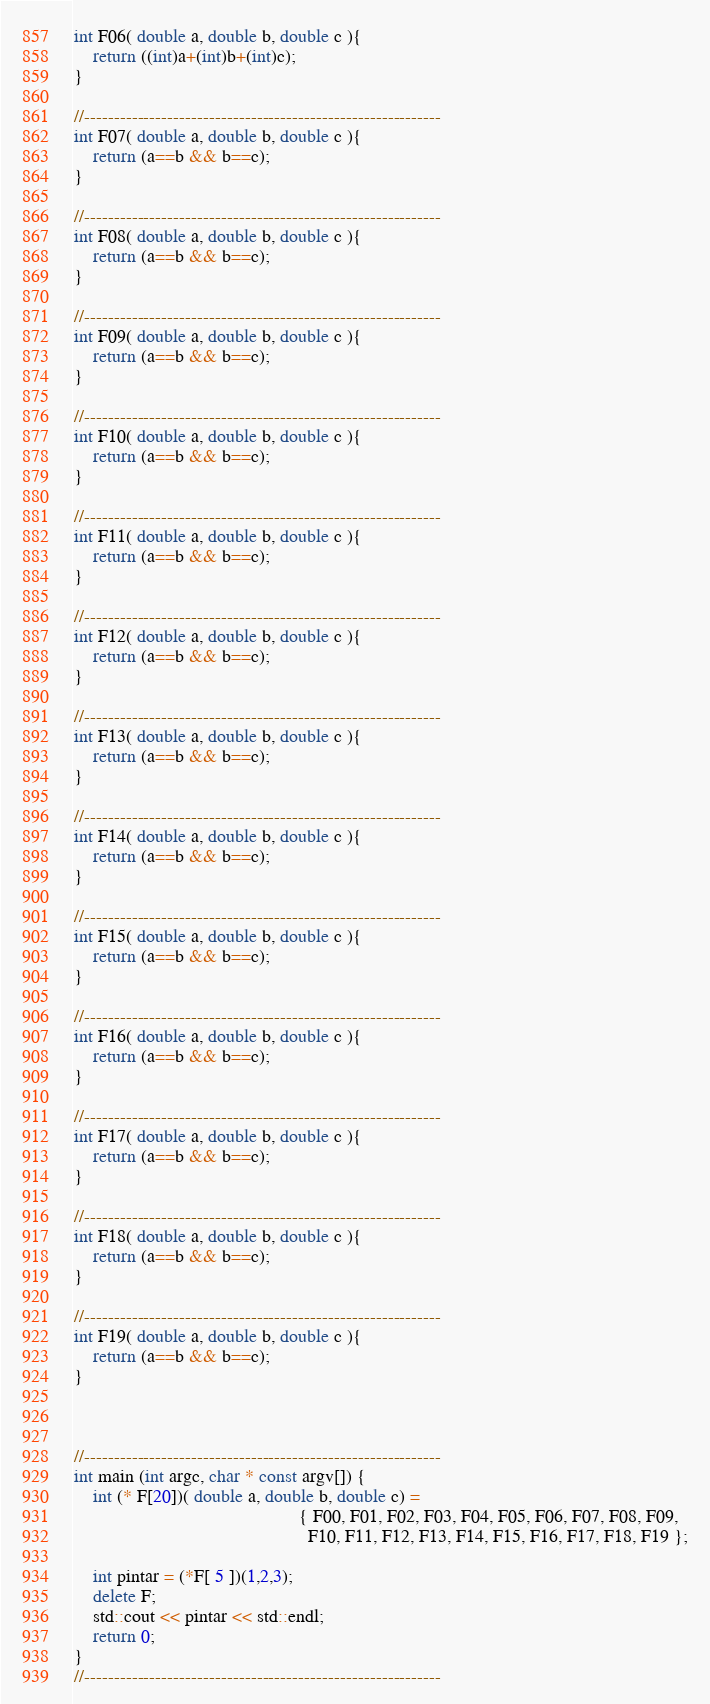<code> <loc_0><loc_0><loc_500><loc_500><_C++_>int F06( double a, double b, double c ){
	return ((int)a+(int)b+(int)c);
}

//------------------------------------------------------------
int F07( double a, double b, double c ){
	return (a==b && b==c);
}

//------------------------------------------------------------
int F08( double a, double b, double c ){
	return (a==b && b==c);
}

//------------------------------------------------------------
int F09( double a, double b, double c ){
	return (a==b && b==c);
}

//------------------------------------------------------------
int F10( double a, double b, double c ){
	return (a==b && b==c);
}

//------------------------------------------------------------
int F11( double a, double b, double c ){
	return (a==b && b==c);
}

//------------------------------------------------------------
int F12( double a, double b, double c ){
	return (a==b && b==c);
}

//------------------------------------------------------------
int F13( double a, double b, double c ){
	return (a==b && b==c);
}

//------------------------------------------------------------
int F14( double a, double b, double c ){
	return (a==b && b==c);
}

//------------------------------------------------------------
int F15( double a, double b, double c ){
	return (a==b && b==c);
}

//------------------------------------------------------------
int F16( double a, double b, double c ){
	return (a==b && b==c);
}

//------------------------------------------------------------
int F17( double a, double b, double c ){
	return (a==b && b==c);
}

//------------------------------------------------------------
int F18( double a, double b, double c ){
	return (a==b && b==c);
}

//------------------------------------------------------------
int F19( double a, double b, double c ){
	return (a==b && b==c);
}



//------------------------------------------------------------
int main (int argc, char * const argv[]) {
	int (* F[20])( double a, double b, double c) =
												{ F00, F01, F02, F03, F04, F05, F06, F07, F08, F09,  
												  F10, F11, F12, F13, F14, F15, F16, F17, F18, F19 };
	
	int pintar = (*F[ 5 ])(1,2,3);
	delete F;
	std::cout << pintar << std::endl;
	return 0;
}
//------------------------------------------------------------
</code> 